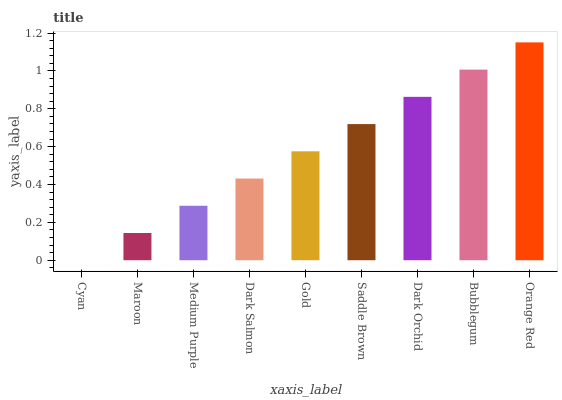Is Cyan the minimum?
Answer yes or no. Yes. Is Orange Red the maximum?
Answer yes or no. Yes. Is Maroon the minimum?
Answer yes or no. No. Is Maroon the maximum?
Answer yes or no. No. Is Maroon greater than Cyan?
Answer yes or no. Yes. Is Cyan less than Maroon?
Answer yes or no. Yes. Is Cyan greater than Maroon?
Answer yes or no. No. Is Maroon less than Cyan?
Answer yes or no. No. Is Gold the high median?
Answer yes or no. Yes. Is Gold the low median?
Answer yes or no. Yes. Is Dark Salmon the high median?
Answer yes or no. No. Is Orange Red the low median?
Answer yes or no. No. 